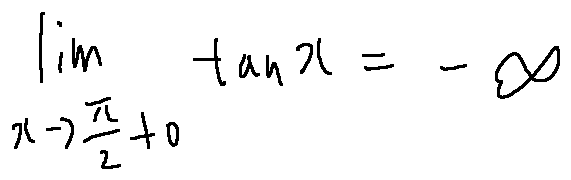Convert formula to latex. <formula><loc_0><loc_0><loc_500><loc_500>\lim \lim i t s _ { x \rightarrow \frac { \pi } { 2 } + 0 } \tan x = - \infty</formula> 